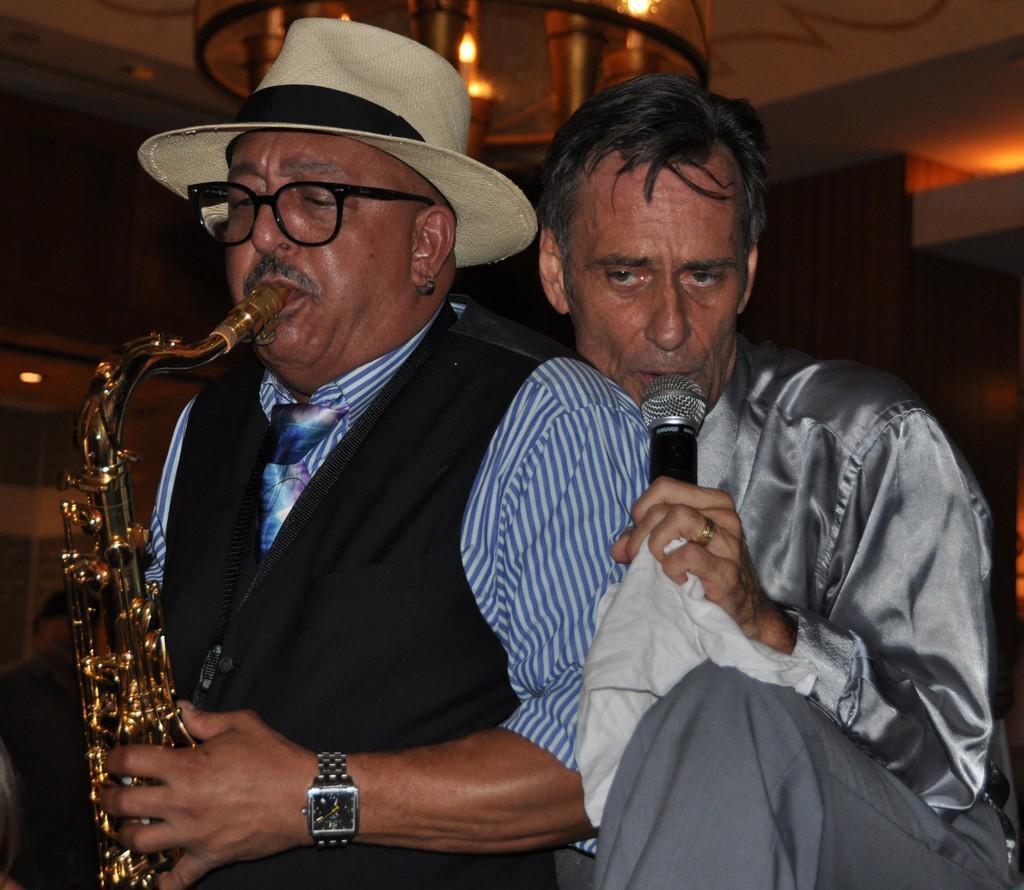Could you give a brief overview of what you see in this image? In this image, There are two persons wearing colorful clothes. The person who is left side of the image playing trumpet and wearing watch, spectacles and hat. The person who is right side of the image holding a mic with his hand. 